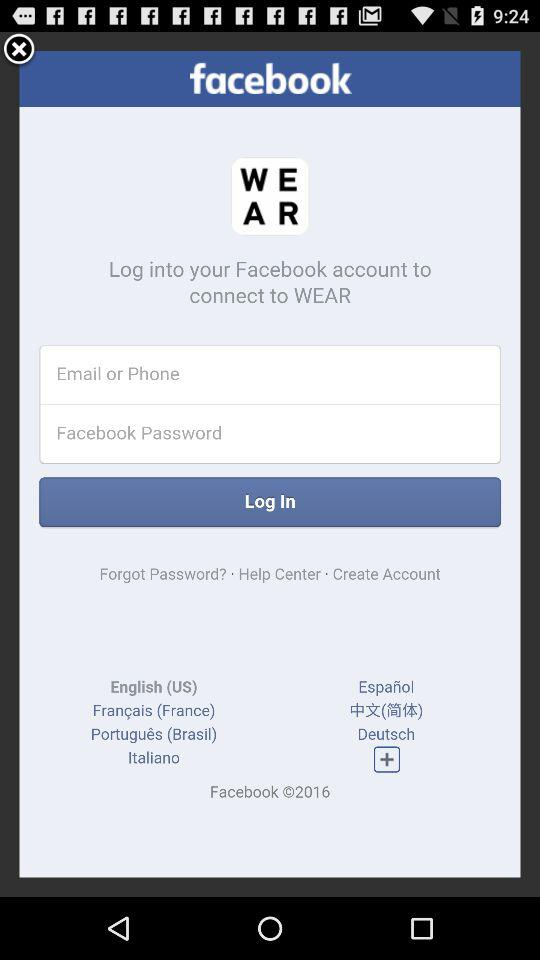How many languages are available for selection on this screen?
Answer the question using a single word or phrase. 7 